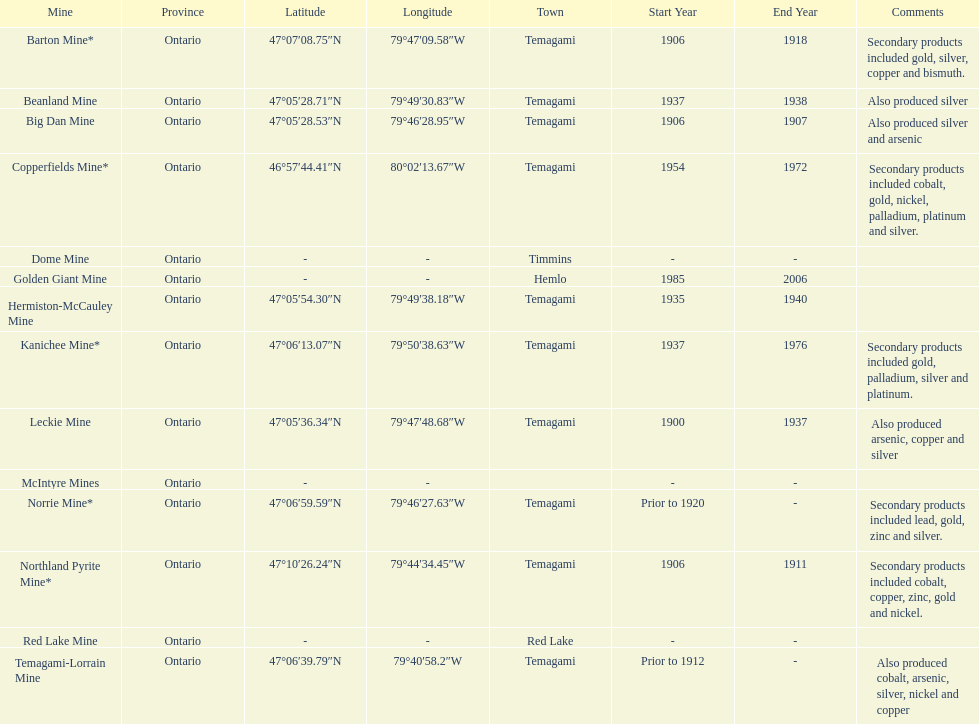Tell me the number of mines that also produced arsenic. 3. 